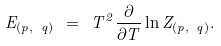<formula> <loc_0><loc_0><loc_500><loc_500>E _ { ( p , \ q ) } \ = \ T ^ { 2 } \frac { \partial } { \partial T } \ln Z _ { ( p , \ q ) } .</formula> 